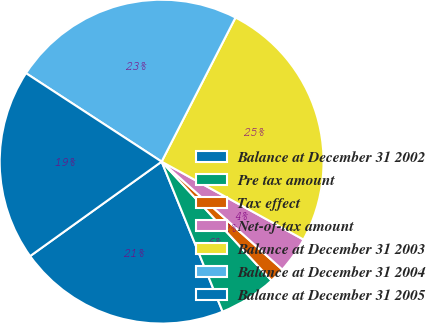Convert chart to OTSL. <chart><loc_0><loc_0><loc_500><loc_500><pie_chart><fcel>Balance at December 31 2002<fcel>Pre tax amount<fcel>Tax effect<fcel>Net-of-tax amount<fcel>Balance at December 31 2003<fcel>Balance at December 31 2004<fcel>Balance at December 31 2005<nl><fcel>21.23%<fcel>5.73%<fcel>1.51%<fcel>3.62%<fcel>25.45%<fcel>23.34%<fcel>19.11%<nl></chart> 